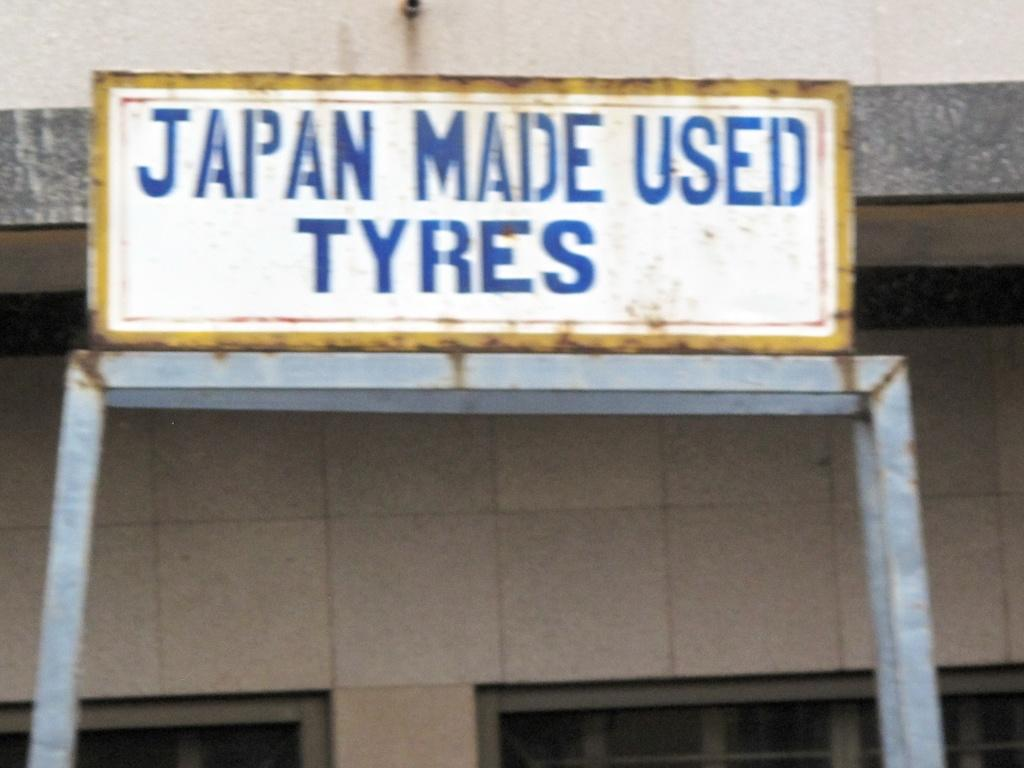What type of object is made of metal in the image? The facts do not specify the type of metal object in the image. What is written on the board in the image? There is a board with text in the image, but the facts do not provide the specific text. What objects are attached to the wall in the background of the image? The facts do not specify the objects attached to the wall in the background. How much does the hair on the wall cost in the image? There is no hair present on the wall in the image, so it is not possible to determine its cost. 